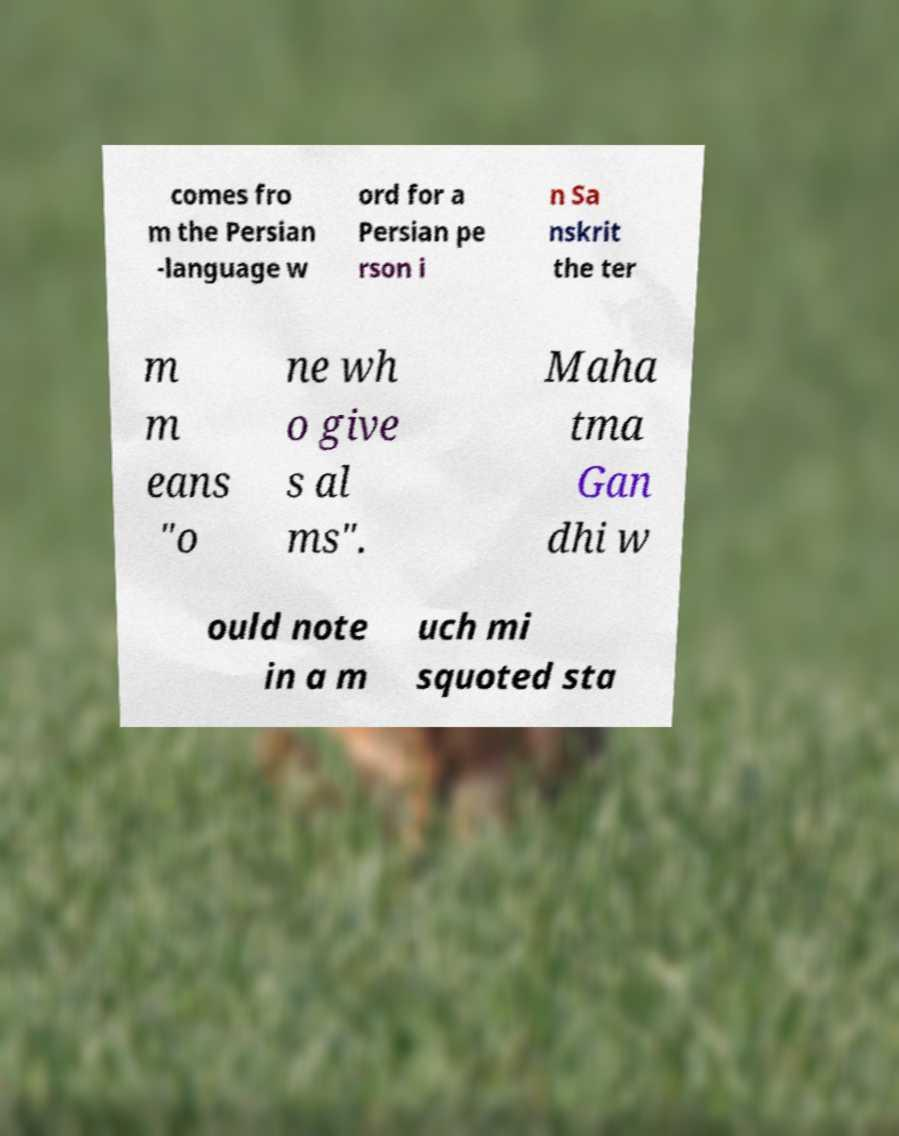Please read and relay the text visible in this image. What does it say? comes fro m the Persian -language w ord for a Persian pe rson i n Sa nskrit the ter m m eans "o ne wh o give s al ms". Maha tma Gan dhi w ould note in a m uch mi squoted sta 